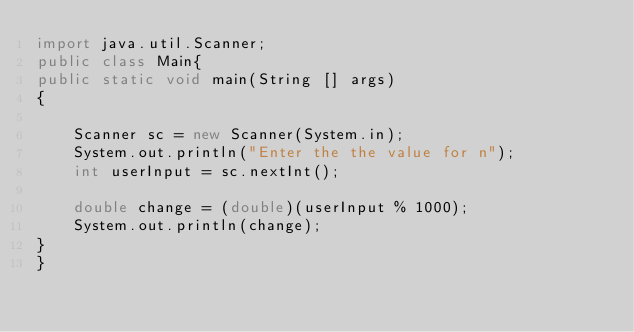Convert code to text. <code><loc_0><loc_0><loc_500><loc_500><_Java_>import java.util.Scanner;
public class Main{
public static void main(String [] args)
{
 
    Scanner sc = new Scanner(System.in);
  	System.out.println("Enter the the value for n");
    int userInput = sc.nextInt();
  
    double change = (double)(userInput % 1000);
  	System.out.println(change);
}
}
</code> 